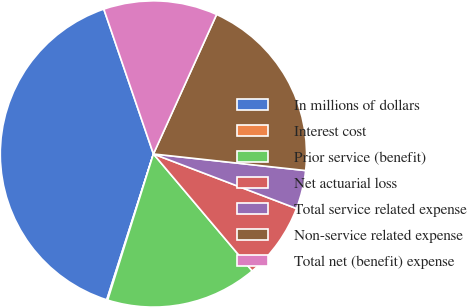<chart> <loc_0><loc_0><loc_500><loc_500><pie_chart><fcel>In millions of dollars<fcel>Interest cost<fcel>Prior service (benefit)<fcel>Net actuarial loss<fcel>Total service related expense<fcel>Non-service related expense<fcel>Total net (benefit) expense<nl><fcel>39.82%<fcel>0.1%<fcel>15.99%<fcel>8.04%<fcel>4.07%<fcel>19.96%<fcel>12.02%<nl></chart> 